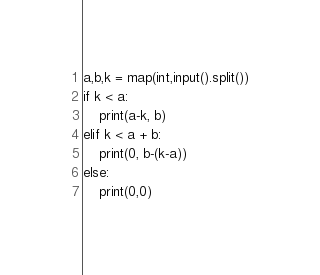<code> <loc_0><loc_0><loc_500><loc_500><_Python_>a,b,k = map(int,input().split())
if k < a:
    print(a-k, b)
elif k < a + b:
    print(0, b-(k-a))
else:
    print(0,0)</code> 